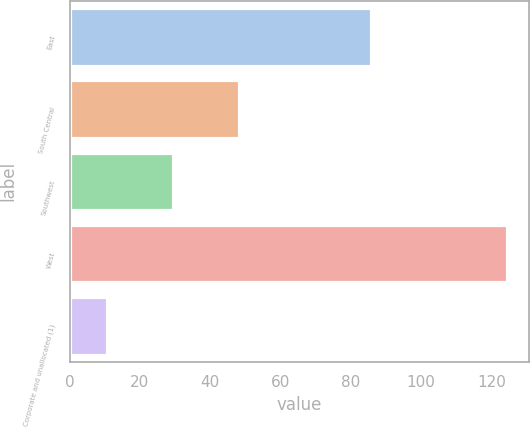Convert chart to OTSL. <chart><loc_0><loc_0><loc_500><loc_500><bar_chart><fcel>East<fcel>South Central<fcel>Southwest<fcel>West<fcel>Corporate and unallocated (1)<nl><fcel>85.8<fcel>48.3<fcel>29.4<fcel>124.5<fcel>10.6<nl></chart> 